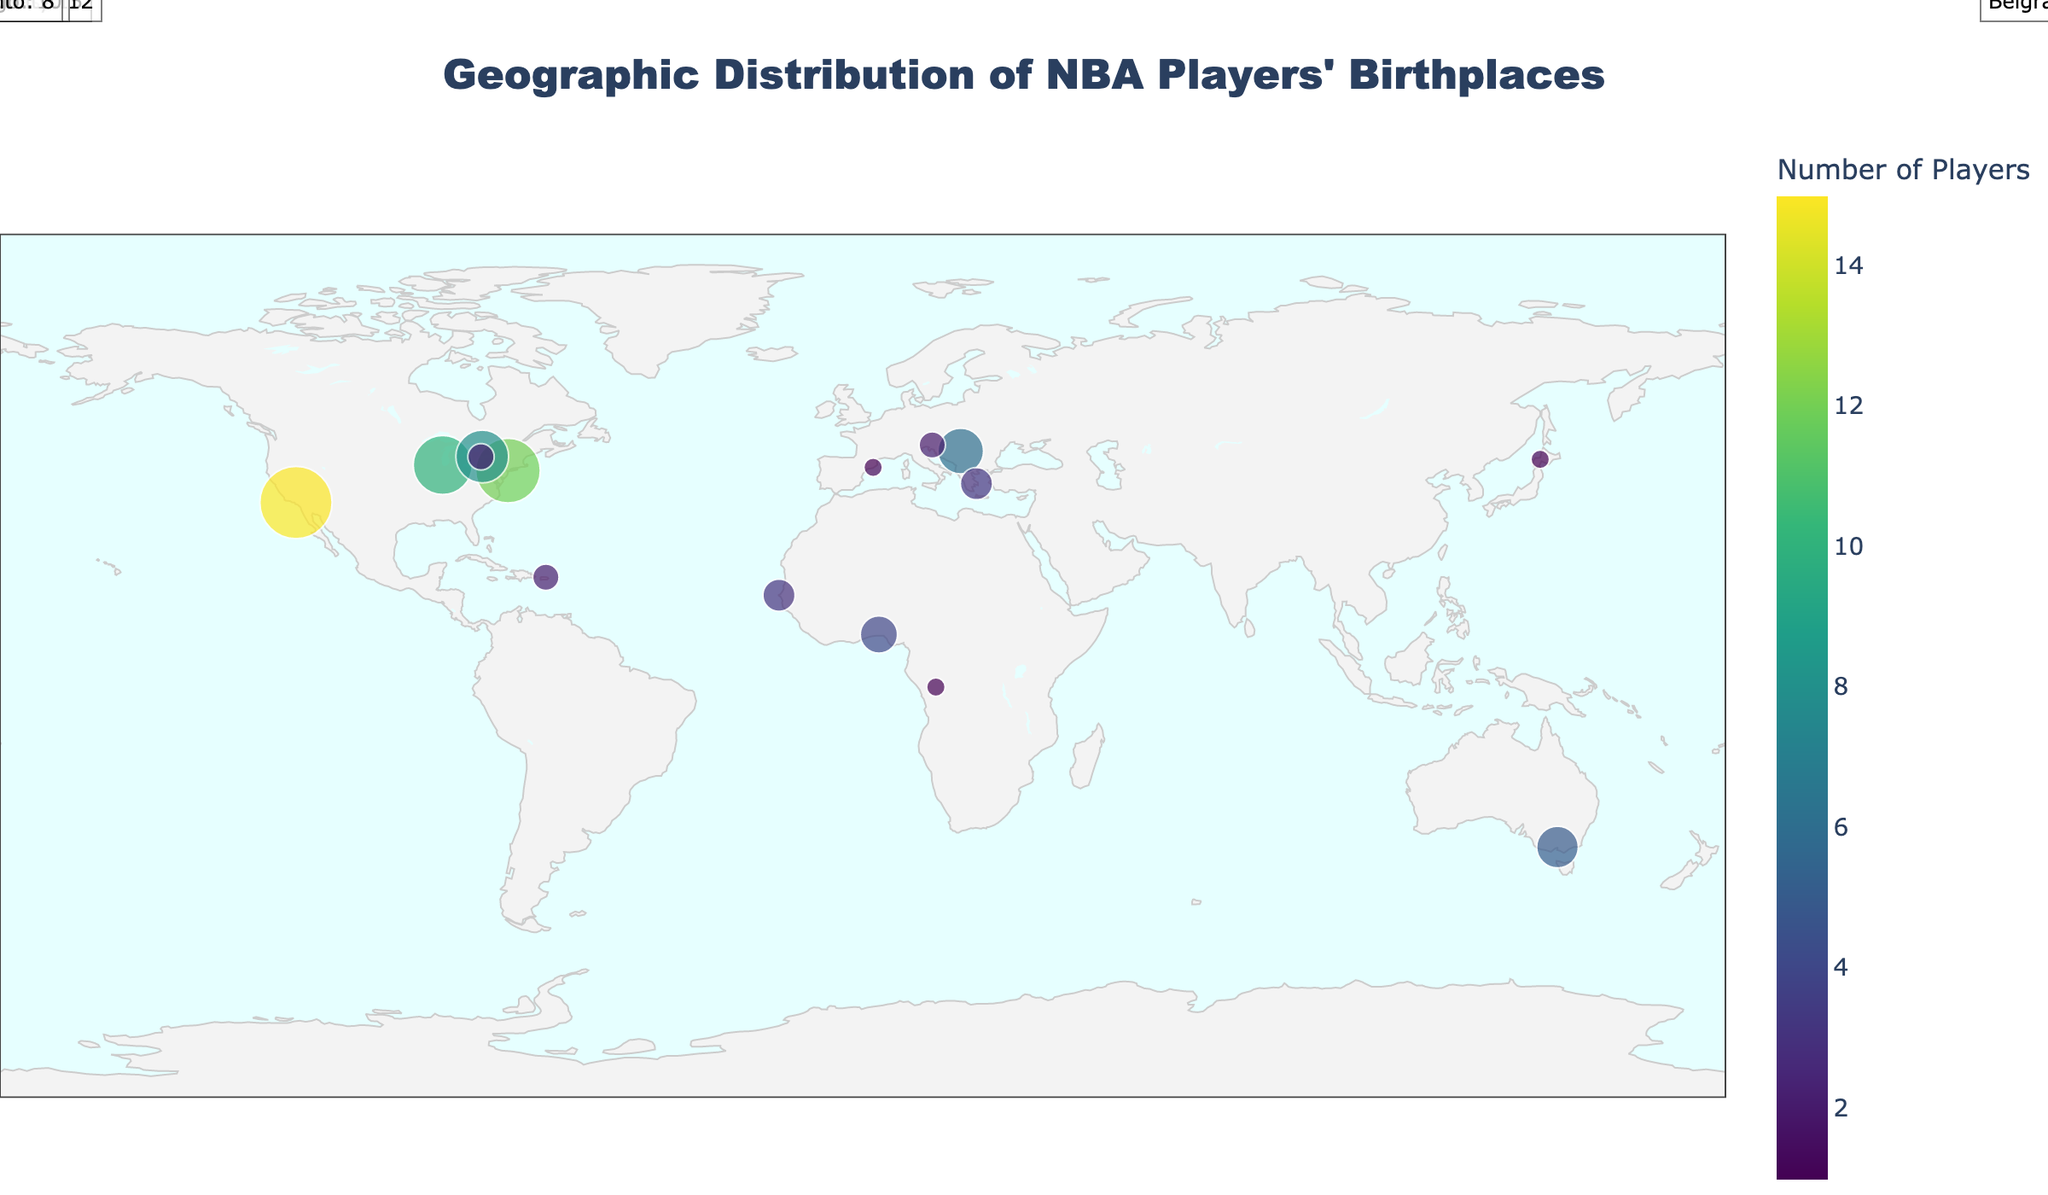what's the title of the plot? The title is usually prominently displayed at the top of the plot, providing an overview of what the data represents. In this case, it reads "Geographic Distribution of NBA Players' Birthplaces."
Answer: Geographic Distribution of NBA Players' Birthplaces how many players were born in New York City? By looking at the size and the color of the dots on the map, and noting the hover data for New York City specifically, we can see the number of players. According to the chart, 12 players were born in New York City.
Answer: 12 which city has the highest number of NBA players' birthplaces? We can determine this by looking for the largest dot on the map and cross-referencing with the hover data. The largest dot corresponds to Los Angeles which has 15 players.
Answer: Los Angeles how many cities have produced exactly 2 NBA players? By examining the data points closely (dot size and related numbers), we see that San Juan, Ljubljana, and Mississauga each have exactly 2 players.
Answer: 3 which non-U.S. city has produced the greatest number of NBA players? By looking at the dots outside the U.S. and considering their sizes and colors representing the number of players, we observe that Toronto in Canada has the highest number with 8 players.
Answer: Toronto compare the number of NBA players born in Belgrade and Chicago. Examining the dots for both cities and their respective hover data, Belgrade has produced 6 players while Chicago has produced 10 players. Comparing these values, Chicago has 4 more players than Belgrade.
Answer: Chicago has 4 more players what is the total number of NBA players born in Canadian cities according to the plot? We identify the Canadian cities (Toronto and Mississauga) and sum their player counts. Toronto has 8 players and Mississauga has 2, giving a total of 10 players.
Answer: 10 how many continents are represented on the map by NBA players' birthplaces? By identifying the dots on different continents (North America, Europe, Africa, Australia, and Asia), we count the distinct continents represented. Each of these continents has at least one city on the map.
Answer: 5 are there more NBA players born in Africa or Europe on the map? We count the players from the African cities (Lagos, Dakar, Kinshasa) and European cities (Belgrade, Athens, Ljubljana, Barcelona). Africa has 8 players (4+3+1) and Europe has 12 players (6+3+2+1). Hence, Europe has more players.
Answer: Europe which city in the southern hemisphere has produced NBA players? By examining the plot for cities situated below the equator, Melbourne in Australia stands out with players, having a latitude of -37.8136 and producing 5 players.
Answer: Melbourne 